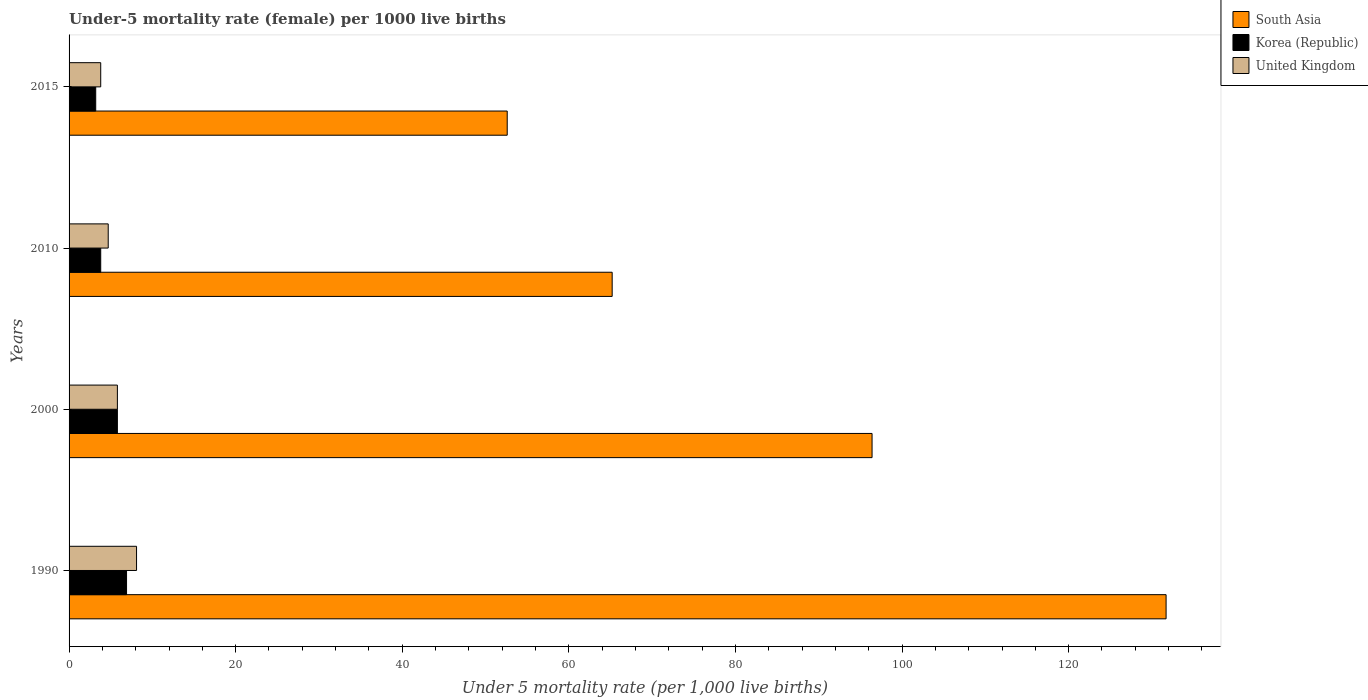How many different coloured bars are there?
Make the answer very short. 3. How many groups of bars are there?
Your response must be concise. 4. Are the number of bars per tick equal to the number of legend labels?
Give a very brief answer. Yes. In how many cases, is the number of bars for a given year not equal to the number of legend labels?
Give a very brief answer. 0. What is the under-five mortality rate in Korea (Republic) in 2000?
Make the answer very short. 5.8. Across all years, what is the maximum under-five mortality rate in South Asia?
Provide a short and direct response. 131.7. Across all years, what is the minimum under-five mortality rate in South Asia?
Make the answer very short. 52.6. In which year was the under-five mortality rate in South Asia minimum?
Your answer should be compact. 2015. What is the total under-five mortality rate in South Asia in the graph?
Keep it short and to the point. 345.9. What is the difference between the under-five mortality rate in South Asia in 2000 and that in 2010?
Offer a very short reply. 31.2. What is the average under-five mortality rate in South Asia per year?
Offer a very short reply. 86.48. In the year 2015, what is the difference between the under-five mortality rate in Korea (Republic) and under-five mortality rate in South Asia?
Provide a succinct answer. -49.4. What is the ratio of the under-five mortality rate in South Asia in 1990 to that in 2000?
Give a very brief answer. 1.37. What does the 3rd bar from the top in 2015 represents?
Give a very brief answer. South Asia. Is it the case that in every year, the sum of the under-five mortality rate in South Asia and under-five mortality rate in United Kingdom is greater than the under-five mortality rate in Korea (Republic)?
Your response must be concise. Yes. How many bars are there?
Provide a short and direct response. 12. What is the difference between two consecutive major ticks on the X-axis?
Your answer should be very brief. 20. Are the values on the major ticks of X-axis written in scientific E-notation?
Offer a terse response. No. Does the graph contain any zero values?
Ensure brevity in your answer.  No. Where does the legend appear in the graph?
Provide a short and direct response. Top right. How many legend labels are there?
Ensure brevity in your answer.  3. How are the legend labels stacked?
Provide a short and direct response. Vertical. What is the title of the graph?
Your response must be concise. Under-5 mortality rate (female) per 1000 live births. What is the label or title of the X-axis?
Ensure brevity in your answer.  Under 5 mortality rate (per 1,0 live births). What is the Under 5 mortality rate (per 1,000 live births) of South Asia in 1990?
Keep it short and to the point. 131.7. What is the Under 5 mortality rate (per 1,000 live births) of United Kingdom in 1990?
Your answer should be compact. 8.1. What is the Under 5 mortality rate (per 1,000 live births) of South Asia in 2000?
Offer a terse response. 96.4. What is the Under 5 mortality rate (per 1,000 live births) in Korea (Republic) in 2000?
Make the answer very short. 5.8. What is the Under 5 mortality rate (per 1,000 live births) in South Asia in 2010?
Give a very brief answer. 65.2. What is the Under 5 mortality rate (per 1,000 live births) in Korea (Republic) in 2010?
Provide a succinct answer. 3.8. What is the Under 5 mortality rate (per 1,000 live births) of South Asia in 2015?
Offer a very short reply. 52.6. Across all years, what is the maximum Under 5 mortality rate (per 1,000 live births) of South Asia?
Make the answer very short. 131.7. Across all years, what is the maximum Under 5 mortality rate (per 1,000 live births) of United Kingdom?
Provide a short and direct response. 8.1. Across all years, what is the minimum Under 5 mortality rate (per 1,000 live births) of South Asia?
Give a very brief answer. 52.6. What is the total Under 5 mortality rate (per 1,000 live births) of South Asia in the graph?
Ensure brevity in your answer.  345.9. What is the total Under 5 mortality rate (per 1,000 live births) in Korea (Republic) in the graph?
Offer a terse response. 19.7. What is the total Under 5 mortality rate (per 1,000 live births) of United Kingdom in the graph?
Your answer should be compact. 22.4. What is the difference between the Under 5 mortality rate (per 1,000 live births) in South Asia in 1990 and that in 2000?
Provide a short and direct response. 35.3. What is the difference between the Under 5 mortality rate (per 1,000 live births) in Korea (Republic) in 1990 and that in 2000?
Keep it short and to the point. 1.1. What is the difference between the Under 5 mortality rate (per 1,000 live births) of United Kingdom in 1990 and that in 2000?
Keep it short and to the point. 2.3. What is the difference between the Under 5 mortality rate (per 1,000 live births) in South Asia in 1990 and that in 2010?
Your response must be concise. 66.5. What is the difference between the Under 5 mortality rate (per 1,000 live births) of United Kingdom in 1990 and that in 2010?
Offer a terse response. 3.4. What is the difference between the Under 5 mortality rate (per 1,000 live births) of South Asia in 1990 and that in 2015?
Your response must be concise. 79.1. What is the difference between the Under 5 mortality rate (per 1,000 live births) of South Asia in 2000 and that in 2010?
Give a very brief answer. 31.2. What is the difference between the Under 5 mortality rate (per 1,000 live births) of Korea (Republic) in 2000 and that in 2010?
Offer a terse response. 2. What is the difference between the Under 5 mortality rate (per 1,000 live births) in South Asia in 2000 and that in 2015?
Your answer should be very brief. 43.8. What is the difference between the Under 5 mortality rate (per 1,000 live births) of Korea (Republic) in 2000 and that in 2015?
Your answer should be compact. 2.6. What is the difference between the Under 5 mortality rate (per 1,000 live births) in United Kingdom in 2000 and that in 2015?
Provide a short and direct response. 2. What is the difference between the Under 5 mortality rate (per 1,000 live births) in South Asia in 2010 and that in 2015?
Offer a very short reply. 12.6. What is the difference between the Under 5 mortality rate (per 1,000 live births) in South Asia in 1990 and the Under 5 mortality rate (per 1,000 live births) in Korea (Republic) in 2000?
Offer a terse response. 125.9. What is the difference between the Under 5 mortality rate (per 1,000 live births) in South Asia in 1990 and the Under 5 mortality rate (per 1,000 live births) in United Kingdom in 2000?
Your answer should be compact. 125.9. What is the difference between the Under 5 mortality rate (per 1,000 live births) in Korea (Republic) in 1990 and the Under 5 mortality rate (per 1,000 live births) in United Kingdom in 2000?
Give a very brief answer. 1.1. What is the difference between the Under 5 mortality rate (per 1,000 live births) in South Asia in 1990 and the Under 5 mortality rate (per 1,000 live births) in Korea (Republic) in 2010?
Ensure brevity in your answer.  127.9. What is the difference between the Under 5 mortality rate (per 1,000 live births) of South Asia in 1990 and the Under 5 mortality rate (per 1,000 live births) of United Kingdom in 2010?
Give a very brief answer. 127. What is the difference between the Under 5 mortality rate (per 1,000 live births) in South Asia in 1990 and the Under 5 mortality rate (per 1,000 live births) in Korea (Republic) in 2015?
Provide a short and direct response. 128.5. What is the difference between the Under 5 mortality rate (per 1,000 live births) of South Asia in 1990 and the Under 5 mortality rate (per 1,000 live births) of United Kingdom in 2015?
Make the answer very short. 127.9. What is the difference between the Under 5 mortality rate (per 1,000 live births) in Korea (Republic) in 1990 and the Under 5 mortality rate (per 1,000 live births) in United Kingdom in 2015?
Provide a succinct answer. 3.1. What is the difference between the Under 5 mortality rate (per 1,000 live births) in South Asia in 2000 and the Under 5 mortality rate (per 1,000 live births) in Korea (Republic) in 2010?
Ensure brevity in your answer.  92.6. What is the difference between the Under 5 mortality rate (per 1,000 live births) in South Asia in 2000 and the Under 5 mortality rate (per 1,000 live births) in United Kingdom in 2010?
Provide a short and direct response. 91.7. What is the difference between the Under 5 mortality rate (per 1,000 live births) of Korea (Republic) in 2000 and the Under 5 mortality rate (per 1,000 live births) of United Kingdom in 2010?
Give a very brief answer. 1.1. What is the difference between the Under 5 mortality rate (per 1,000 live births) in South Asia in 2000 and the Under 5 mortality rate (per 1,000 live births) in Korea (Republic) in 2015?
Offer a very short reply. 93.2. What is the difference between the Under 5 mortality rate (per 1,000 live births) of South Asia in 2000 and the Under 5 mortality rate (per 1,000 live births) of United Kingdom in 2015?
Give a very brief answer. 92.6. What is the difference between the Under 5 mortality rate (per 1,000 live births) in Korea (Republic) in 2000 and the Under 5 mortality rate (per 1,000 live births) in United Kingdom in 2015?
Your answer should be very brief. 2. What is the difference between the Under 5 mortality rate (per 1,000 live births) of South Asia in 2010 and the Under 5 mortality rate (per 1,000 live births) of Korea (Republic) in 2015?
Your answer should be very brief. 62. What is the difference between the Under 5 mortality rate (per 1,000 live births) of South Asia in 2010 and the Under 5 mortality rate (per 1,000 live births) of United Kingdom in 2015?
Ensure brevity in your answer.  61.4. What is the average Under 5 mortality rate (per 1,000 live births) of South Asia per year?
Provide a succinct answer. 86.47. What is the average Under 5 mortality rate (per 1,000 live births) of Korea (Republic) per year?
Give a very brief answer. 4.92. In the year 1990, what is the difference between the Under 5 mortality rate (per 1,000 live births) in South Asia and Under 5 mortality rate (per 1,000 live births) in Korea (Republic)?
Your answer should be very brief. 124.8. In the year 1990, what is the difference between the Under 5 mortality rate (per 1,000 live births) in South Asia and Under 5 mortality rate (per 1,000 live births) in United Kingdom?
Keep it short and to the point. 123.6. In the year 2000, what is the difference between the Under 5 mortality rate (per 1,000 live births) in South Asia and Under 5 mortality rate (per 1,000 live births) in Korea (Republic)?
Make the answer very short. 90.6. In the year 2000, what is the difference between the Under 5 mortality rate (per 1,000 live births) in South Asia and Under 5 mortality rate (per 1,000 live births) in United Kingdom?
Your answer should be very brief. 90.6. In the year 2010, what is the difference between the Under 5 mortality rate (per 1,000 live births) of South Asia and Under 5 mortality rate (per 1,000 live births) of Korea (Republic)?
Keep it short and to the point. 61.4. In the year 2010, what is the difference between the Under 5 mortality rate (per 1,000 live births) in South Asia and Under 5 mortality rate (per 1,000 live births) in United Kingdom?
Offer a very short reply. 60.5. In the year 2010, what is the difference between the Under 5 mortality rate (per 1,000 live births) in Korea (Republic) and Under 5 mortality rate (per 1,000 live births) in United Kingdom?
Keep it short and to the point. -0.9. In the year 2015, what is the difference between the Under 5 mortality rate (per 1,000 live births) in South Asia and Under 5 mortality rate (per 1,000 live births) in Korea (Republic)?
Your answer should be very brief. 49.4. In the year 2015, what is the difference between the Under 5 mortality rate (per 1,000 live births) of South Asia and Under 5 mortality rate (per 1,000 live births) of United Kingdom?
Provide a succinct answer. 48.8. In the year 2015, what is the difference between the Under 5 mortality rate (per 1,000 live births) in Korea (Republic) and Under 5 mortality rate (per 1,000 live births) in United Kingdom?
Provide a short and direct response. -0.6. What is the ratio of the Under 5 mortality rate (per 1,000 live births) in South Asia in 1990 to that in 2000?
Your answer should be very brief. 1.37. What is the ratio of the Under 5 mortality rate (per 1,000 live births) of Korea (Republic) in 1990 to that in 2000?
Provide a short and direct response. 1.19. What is the ratio of the Under 5 mortality rate (per 1,000 live births) in United Kingdom in 1990 to that in 2000?
Keep it short and to the point. 1.4. What is the ratio of the Under 5 mortality rate (per 1,000 live births) in South Asia in 1990 to that in 2010?
Provide a short and direct response. 2.02. What is the ratio of the Under 5 mortality rate (per 1,000 live births) in Korea (Republic) in 1990 to that in 2010?
Your answer should be compact. 1.82. What is the ratio of the Under 5 mortality rate (per 1,000 live births) in United Kingdom in 1990 to that in 2010?
Your answer should be compact. 1.72. What is the ratio of the Under 5 mortality rate (per 1,000 live births) in South Asia in 1990 to that in 2015?
Offer a terse response. 2.5. What is the ratio of the Under 5 mortality rate (per 1,000 live births) in Korea (Republic) in 1990 to that in 2015?
Offer a terse response. 2.16. What is the ratio of the Under 5 mortality rate (per 1,000 live births) of United Kingdom in 1990 to that in 2015?
Ensure brevity in your answer.  2.13. What is the ratio of the Under 5 mortality rate (per 1,000 live births) in South Asia in 2000 to that in 2010?
Keep it short and to the point. 1.48. What is the ratio of the Under 5 mortality rate (per 1,000 live births) in Korea (Republic) in 2000 to that in 2010?
Give a very brief answer. 1.53. What is the ratio of the Under 5 mortality rate (per 1,000 live births) in United Kingdom in 2000 to that in 2010?
Ensure brevity in your answer.  1.23. What is the ratio of the Under 5 mortality rate (per 1,000 live births) in South Asia in 2000 to that in 2015?
Your answer should be compact. 1.83. What is the ratio of the Under 5 mortality rate (per 1,000 live births) of Korea (Republic) in 2000 to that in 2015?
Your answer should be very brief. 1.81. What is the ratio of the Under 5 mortality rate (per 1,000 live births) of United Kingdom in 2000 to that in 2015?
Provide a short and direct response. 1.53. What is the ratio of the Under 5 mortality rate (per 1,000 live births) in South Asia in 2010 to that in 2015?
Your answer should be compact. 1.24. What is the ratio of the Under 5 mortality rate (per 1,000 live births) in Korea (Republic) in 2010 to that in 2015?
Give a very brief answer. 1.19. What is the ratio of the Under 5 mortality rate (per 1,000 live births) in United Kingdom in 2010 to that in 2015?
Your answer should be compact. 1.24. What is the difference between the highest and the second highest Under 5 mortality rate (per 1,000 live births) of South Asia?
Offer a very short reply. 35.3. What is the difference between the highest and the second highest Under 5 mortality rate (per 1,000 live births) of Korea (Republic)?
Keep it short and to the point. 1.1. What is the difference between the highest and the second highest Under 5 mortality rate (per 1,000 live births) in United Kingdom?
Give a very brief answer. 2.3. What is the difference between the highest and the lowest Under 5 mortality rate (per 1,000 live births) of South Asia?
Your response must be concise. 79.1. What is the difference between the highest and the lowest Under 5 mortality rate (per 1,000 live births) of Korea (Republic)?
Your answer should be compact. 3.7. 